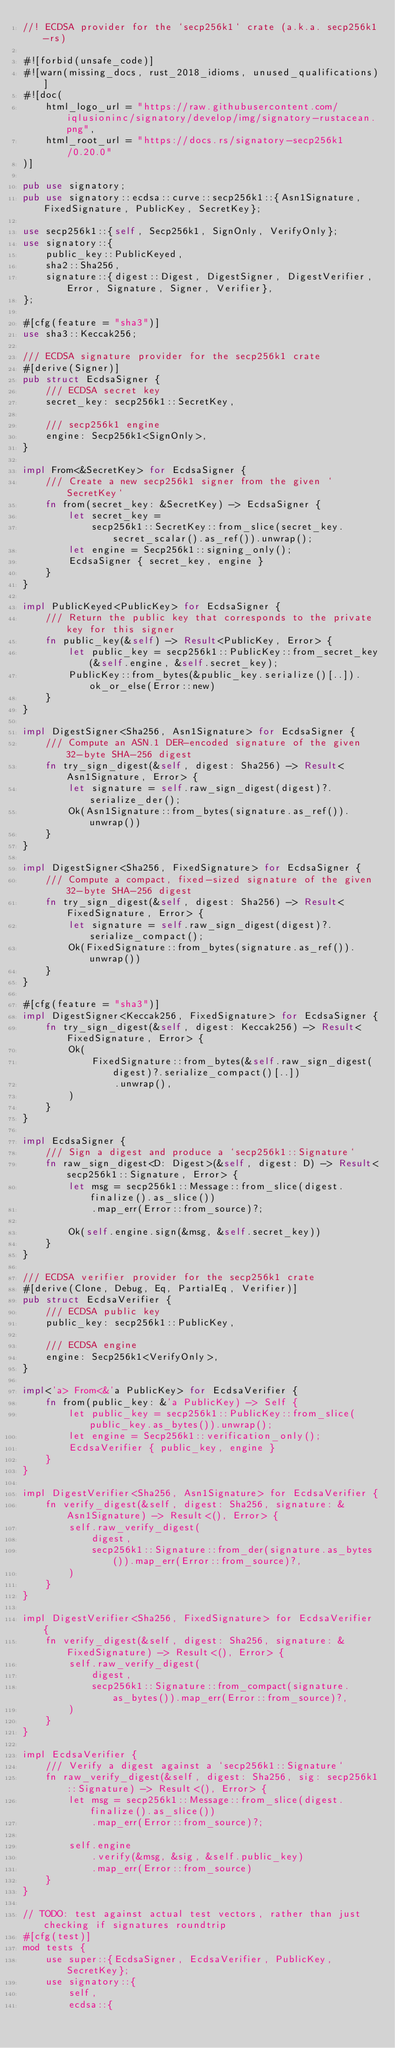<code> <loc_0><loc_0><loc_500><loc_500><_Rust_>//! ECDSA provider for the `secp256k1` crate (a.k.a. secp256k1-rs)

#![forbid(unsafe_code)]
#![warn(missing_docs, rust_2018_idioms, unused_qualifications)]
#![doc(
    html_logo_url = "https://raw.githubusercontent.com/iqlusioninc/signatory/develop/img/signatory-rustacean.png",
    html_root_url = "https://docs.rs/signatory-secp256k1/0.20.0"
)]

pub use signatory;
pub use signatory::ecdsa::curve::secp256k1::{Asn1Signature, FixedSignature, PublicKey, SecretKey};

use secp256k1::{self, Secp256k1, SignOnly, VerifyOnly};
use signatory::{
    public_key::PublicKeyed,
    sha2::Sha256,
    signature::{digest::Digest, DigestSigner, DigestVerifier, Error, Signature, Signer, Verifier},
};

#[cfg(feature = "sha3")]
use sha3::Keccak256;

/// ECDSA signature provider for the secp256k1 crate
#[derive(Signer)]
pub struct EcdsaSigner {
    /// ECDSA secret key
    secret_key: secp256k1::SecretKey,

    /// secp256k1 engine
    engine: Secp256k1<SignOnly>,
}

impl From<&SecretKey> for EcdsaSigner {
    /// Create a new secp256k1 signer from the given `SecretKey`
    fn from(secret_key: &SecretKey) -> EcdsaSigner {
        let secret_key =
            secp256k1::SecretKey::from_slice(secret_key.secret_scalar().as_ref()).unwrap();
        let engine = Secp256k1::signing_only();
        EcdsaSigner { secret_key, engine }
    }
}

impl PublicKeyed<PublicKey> for EcdsaSigner {
    /// Return the public key that corresponds to the private key for this signer
    fn public_key(&self) -> Result<PublicKey, Error> {
        let public_key = secp256k1::PublicKey::from_secret_key(&self.engine, &self.secret_key);
        PublicKey::from_bytes(&public_key.serialize()[..]).ok_or_else(Error::new)
    }
}

impl DigestSigner<Sha256, Asn1Signature> for EcdsaSigner {
    /// Compute an ASN.1 DER-encoded signature of the given 32-byte SHA-256 digest
    fn try_sign_digest(&self, digest: Sha256) -> Result<Asn1Signature, Error> {
        let signature = self.raw_sign_digest(digest)?.serialize_der();
        Ok(Asn1Signature::from_bytes(signature.as_ref()).unwrap())
    }
}

impl DigestSigner<Sha256, FixedSignature> for EcdsaSigner {
    /// Compute a compact, fixed-sized signature of the given 32-byte SHA-256 digest
    fn try_sign_digest(&self, digest: Sha256) -> Result<FixedSignature, Error> {
        let signature = self.raw_sign_digest(digest)?.serialize_compact();
        Ok(FixedSignature::from_bytes(signature.as_ref()).unwrap())
    }
}

#[cfg(feature = "sha3")]
impl DigestSigner<Keccak256, FixedSignature> for EcdsaSigner {
    fn try_sign_digest(&self, digest: Keccak256) -> Result<FixedSignature, Error> {
        Ok(
            FixedSignature::from_bytes(&self.raw_sign_digest(digest)?.serialize_compact()[..])
                .unwrap(),
        )
    }
}

impl EcdsaSigner {
    /// Sign a digest and produce a `secp256k1::Signature`
    fn raw_sign_digest<D: Digest>(&self, digest: D) -> Result<secp256k1::Signature, Error> {
        let msg = secp256k1::Message::from_slice(digest.finalize().as_slice())
            .map_err(Error::from_source)?;

        Ok(self.engine.sign(&msg, &self.secret_key))
    }
}

/// ECDSA verifier provider for the secp256k1 crate
#[derive(Clone, Debug, Eq, PartialEq, Verifier)]
pub struct EcdsaVerifier {
    /// ECDSA public key
    public_key: secp256k1::PublicKey,

    /// ECDSA engine
    engine: Secp256k1<VerifyOnly>,
}

impl<'a> From<&'a PublicKey> for EcdsaVerifier {
    fn from(public_key: &'a PublicKey) -> Self {
        let public_key = secp256k1::PublicKey::from_slice(public_key.as_bytes()).unwrap();
        let engine = Secp256k1::verification_only();
        EcdsaVerifier { public_key, engine }
    }
}

impl DigestVerifier<Sha256, Asn1Signature> for EcdsaVerifier {
    fn verify_digest(&self, digest: Sha256, signature: &Asn1Signature) -> Result<(), Error> {
        self.raw_verify_digest(
            digest,
            secp256k1::Signature::from_der(signature.as_bytes()).map_err(Error::from_source)?,
        )
    }
}

impl DigestVerifier<Sha256, FixedSignature> for EcdsaVerifier {
    fn verify_digest(&self, digest: Sha256, signature: &FixedSignature) -> Result<(), Error> {
        self.raw_verify_digest(
            digest,
            secp256k1::Signature::from_compact(signature.as_bytes()).map_err(Error::from_source)?,
        )
    }
}

impl EcdsaVerifier {
    /// Verify a digest against a `secp256k1::Signature`
    fn raw_verify_digest(&self, digest: Sha256, sig: secp256k1::Signature) -> Result<(), Error> {
        let msg = secp256k1::Message::from_slice(digest.finalize().as_slice())
            .map_err(Error::from_source)?;

        self.engine
            .verify(&msg, &sig, &self.public_key)
            .map_err(Error::from_source)
    }
}

// TODO: test against actual test vectors, rather than just checking if signatures roundtrip
#[cfg(test)]
mod tests {
    use super::{EcdsaSigner, EcdsaVerifier, PublicKey, SecretKey};
    use signatory::{
        self,
        ecdsa::{</code> 